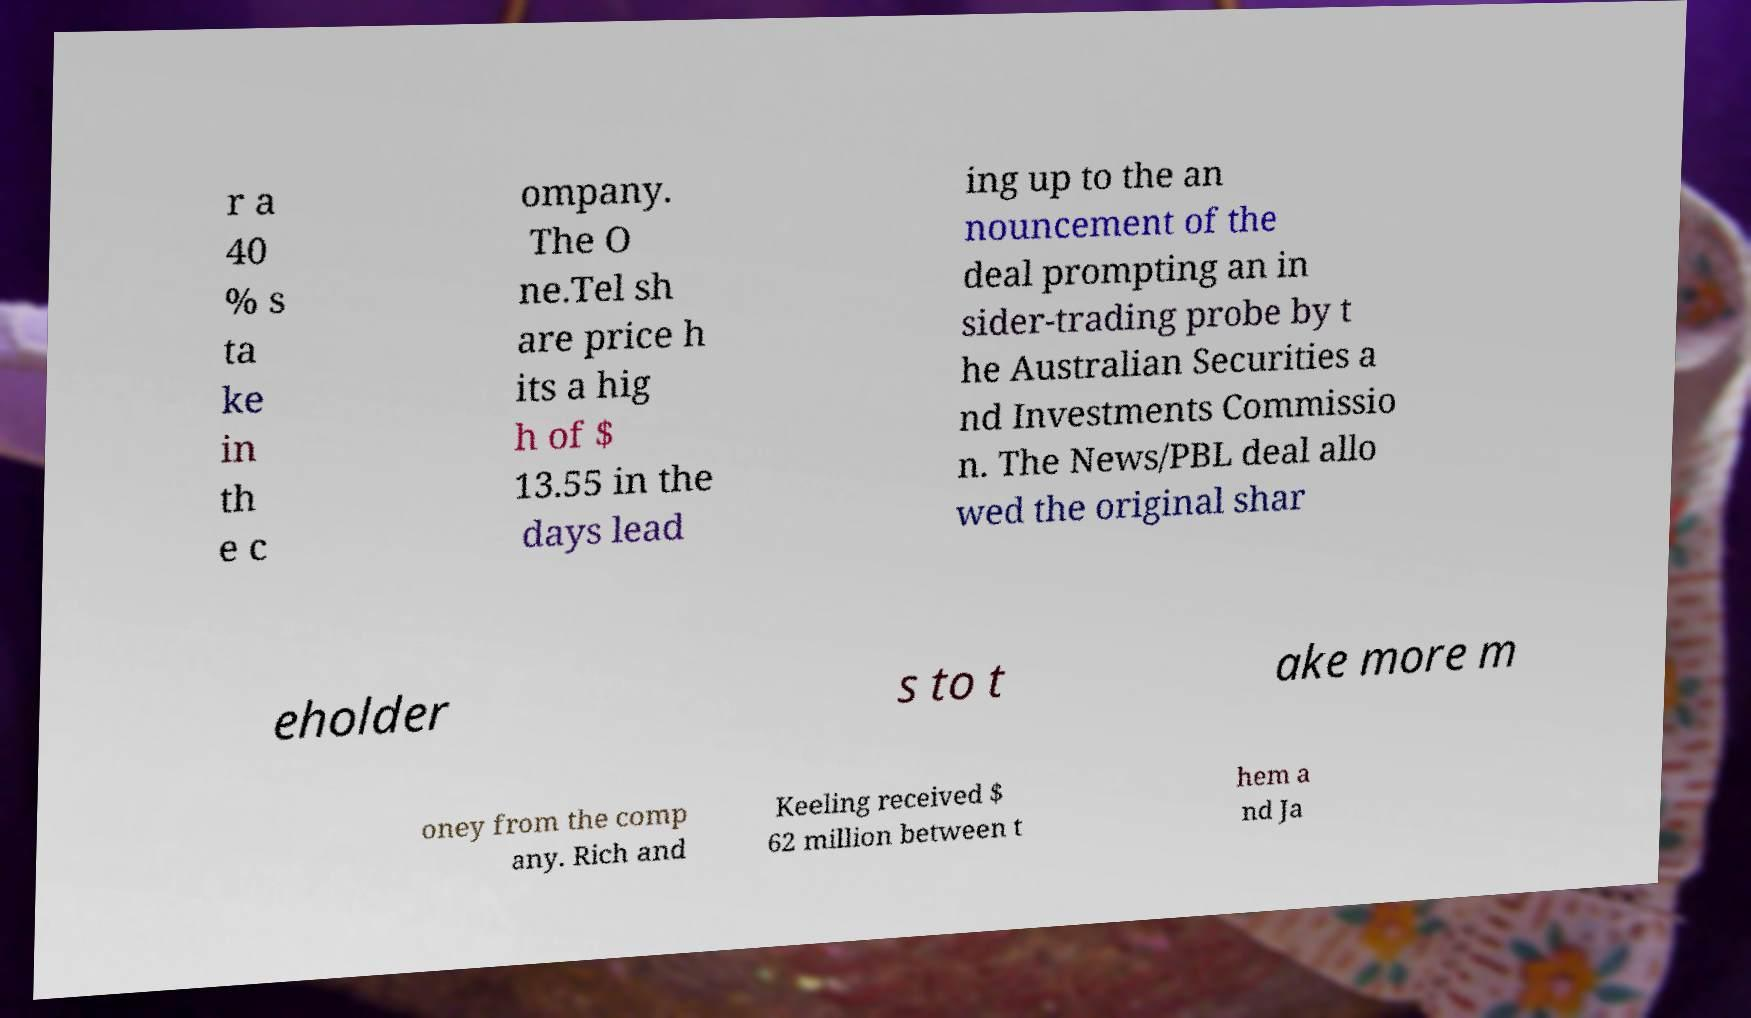I need the written content from this picture converted into text. Can you do that? r a 40 % s ta ke in th e c ompany. The O ne.Tel sh are price h its a hig h of $ 13.55 in the days lead ing up to the an nouncement of the deal prompting an in sider-trading probe by t he Australian Securities a nd Investments Commissio n. The News/PBL deal allo wed the original shar eholder s to t ake more m oney from the comp any. Rich and Keeling received $ 62 million between t hem a nd Ja 